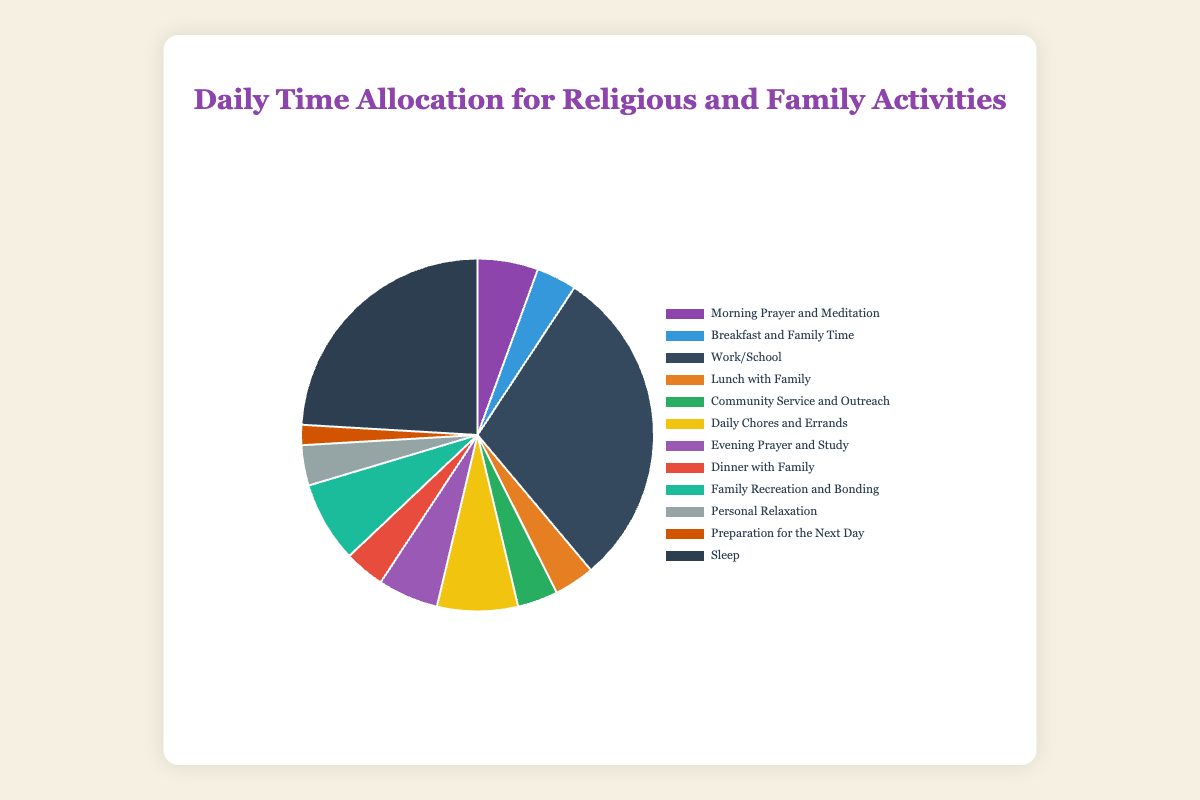What is the total amount of time allocated to prayer and study activities? To find the total time for prayer and study activities, add up the hours for "Morning Prayer and Meditation" (1.5 hours) and "Evening Prayer and Study" (1.5 hours): 1.5 + 1.5 = 3 hours.
Answer: 3 hours Which activity takes up the most time in the day? By comparing the hours allocated to each activity, "Work/School" has the highest value with 8 hours.
Answer: Work/School How much more time is spent on "Daily Chores and Errands" compared to "Preparation for the Next Day"? Subtract the hours for "Preparation for the Next Day" (0.5 hours) from "Daily Chores and Errands" (2 hours): 2 - 0.5 = 1.5 hours.
Answer: 1.5 hours What is the combined time spent on meals with family (Breakfast, Lunch, and Dinner)? Add the hours allocated to "Breakfast and Family Time" (1 hour), "Lunch with Family" (1 hour), and "Dinner with Family" (1 hour): 1 + 1 + 1 = 3 hours.
Answer: 3 hours How does the time spent on "Family Recreation and Bonding" compare to "Community Service and Outreach"? Compare the hours: "Family Recreation and Bonding" is 2 hours, while "Community Service and Outreach" is 1 hour. Therefore, "Family Recreation and Bonding" takes 1 hour more.
Answer: 1 hour more What percentage of the day is dedicated to sleep? To find the percentage of the day dedicated to sleep, divide the hours for "Sleep" (6.5) by the total number of hours in a day (24), then multiply by 100: (6.5 / 24) * 100 = 27.08%.
Answer: 27.08% How much time is spent on personal relaxation in comparison to morning and evening prayer combined? Personal relaxation is 1 hour. The combined time for morning and evening prayer is 3 hours (1.5 + 1.5). Personal relaxation is 2 hours less than prayer.
Answer: 2 hours less If we combine "Daily Chores and Errands" and "Preparation for the Next Day", what is the total time spent? Add the hours for "Daily Chores and Errands" (2 hours) and "Preparation for the Next Day" (0.5 hours): 2 + 0.5 = 2.5 hours.
Answer: 2.5 hours What color represents "Community Service and Outreach" in the pie chart? The pie chart uses distinct colors for each activity. "Community Service and Outreach" is represented by green.
Answer: Green 